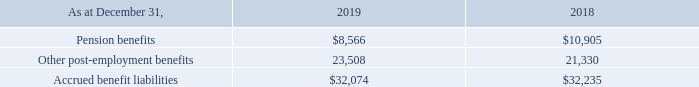In October 2013, the Company ceased to allow new employees to join certain defined benefit plans, except under certain circumstances, and commenced a defined contribution pension plan for new employees.
The Company made contributions of $1.2 million for various defined contribution arrangements during 2019 (December 31, 2018 — $0.9 million).
The Company’s funding policy is to make contributions to its defined benefit pension funds based on actuarial cost methods as permitted and required by pension regulatory bodies. Contributions reflect actuarial assumptions concerning future investment returns, salary projections and future service benefits. Plan assets are represented primarily by Canadian and foreign equity securities, fixed income instruments and short-term investments.
The Company provides certain health care and life insurance benefits for some of its retired employees and their dependents. Participants are eligible for these benefits generally when they retire from active service and meet the eligibility requirements for the pension plan. These benefits are funded primarily on a pay-as-you-go basis, with the retiree generally paying a portion of the cost through contributions, deductibles and coinsurance provisions.
The balance sheet obligations, distributed between pension and other post-employment benefits, included in other long-term liabilities (Note 23) were as follows:
When did the company crease to allow new employees to join certain defined benefit plans, except under certain circumstances? October 2013. What are the respective contributions made by the company for various defined contribution arrangements in 2018 and 2019 respectively?
Answer scale should be: million. $0.9, $1.2. What are the company's respective accrued benefit liabilities as at December 31, 2018 and 2019 respectively? $32,235, $32,074. What is the company's total accrued benefits as at December 31, 2018 and 2019? 32,235 +32,074 
Answer: 64309. What is the company's percentage change in other post-employment benefits between 2018 and 2019?
Answer scale should be: percent. (23,508 - 21,330)/21,330 
Answer: 10.21. What is the total pension benefits accrued by the company in 2018 and 2019? 8,566 + 10,905 
Answer: 19471. 